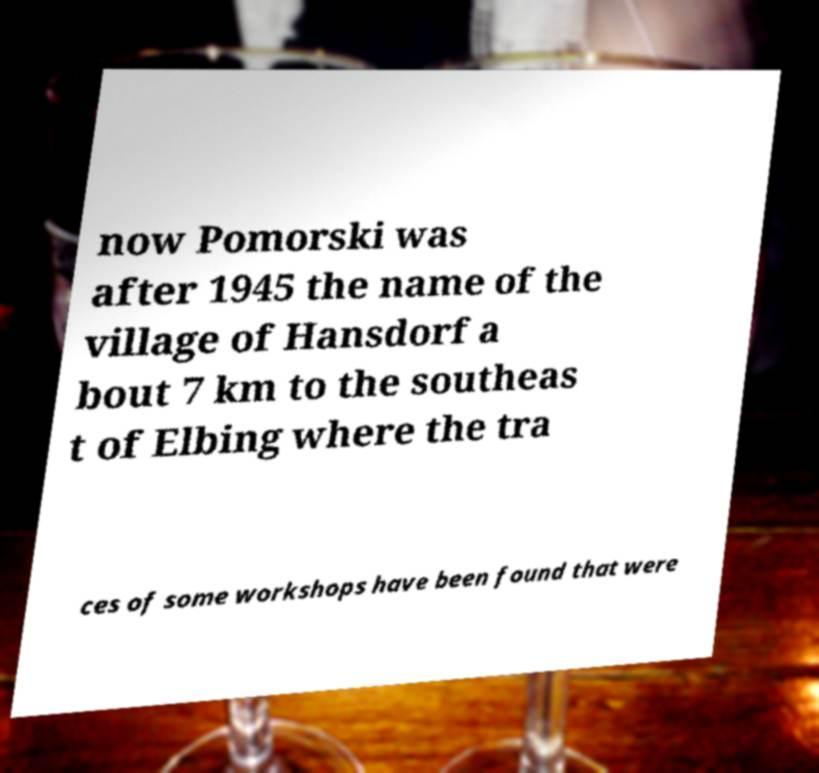Please read and relay the text visible in this image. What does it say? now Pomorski was after 1945 the name of the village of Hansdorf a bout 7 km to the southeas t of Elbing where the tra ces of some workshops have been found that were 